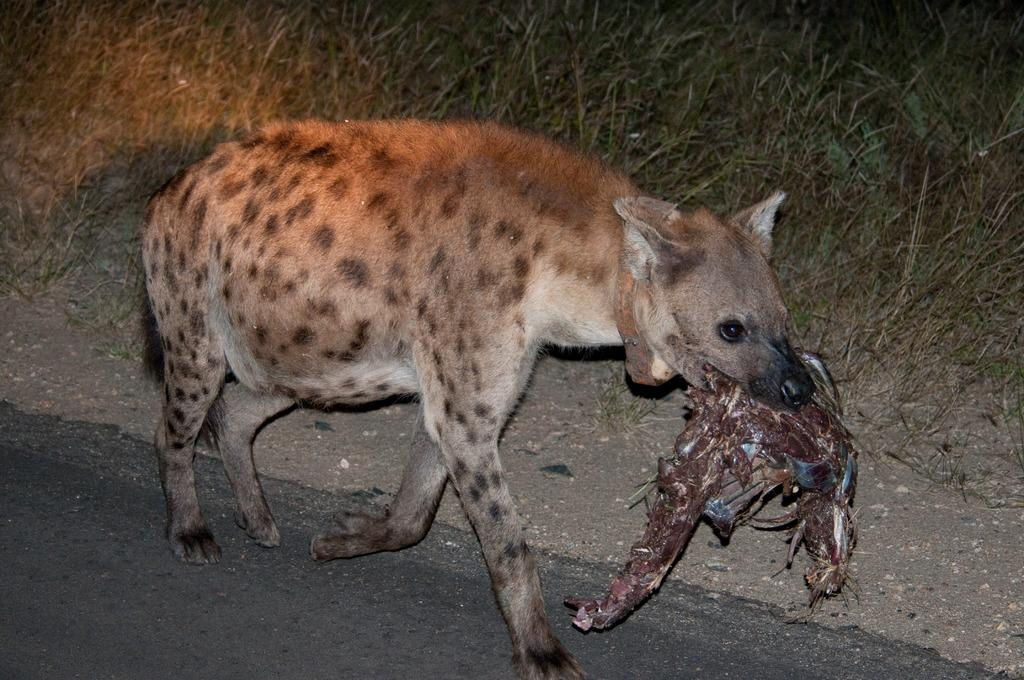What animal is present in the image? There is a hyena in the image. What is the hyena doing in the image? The hyena is walking on a road in the image. What type of terrain can be seen in the image? There is grass visible in the image. What type of experience does the maid have with the hyena in the image? There is no maid present in the image, so it is not possible to determine any experience with the hyena. 